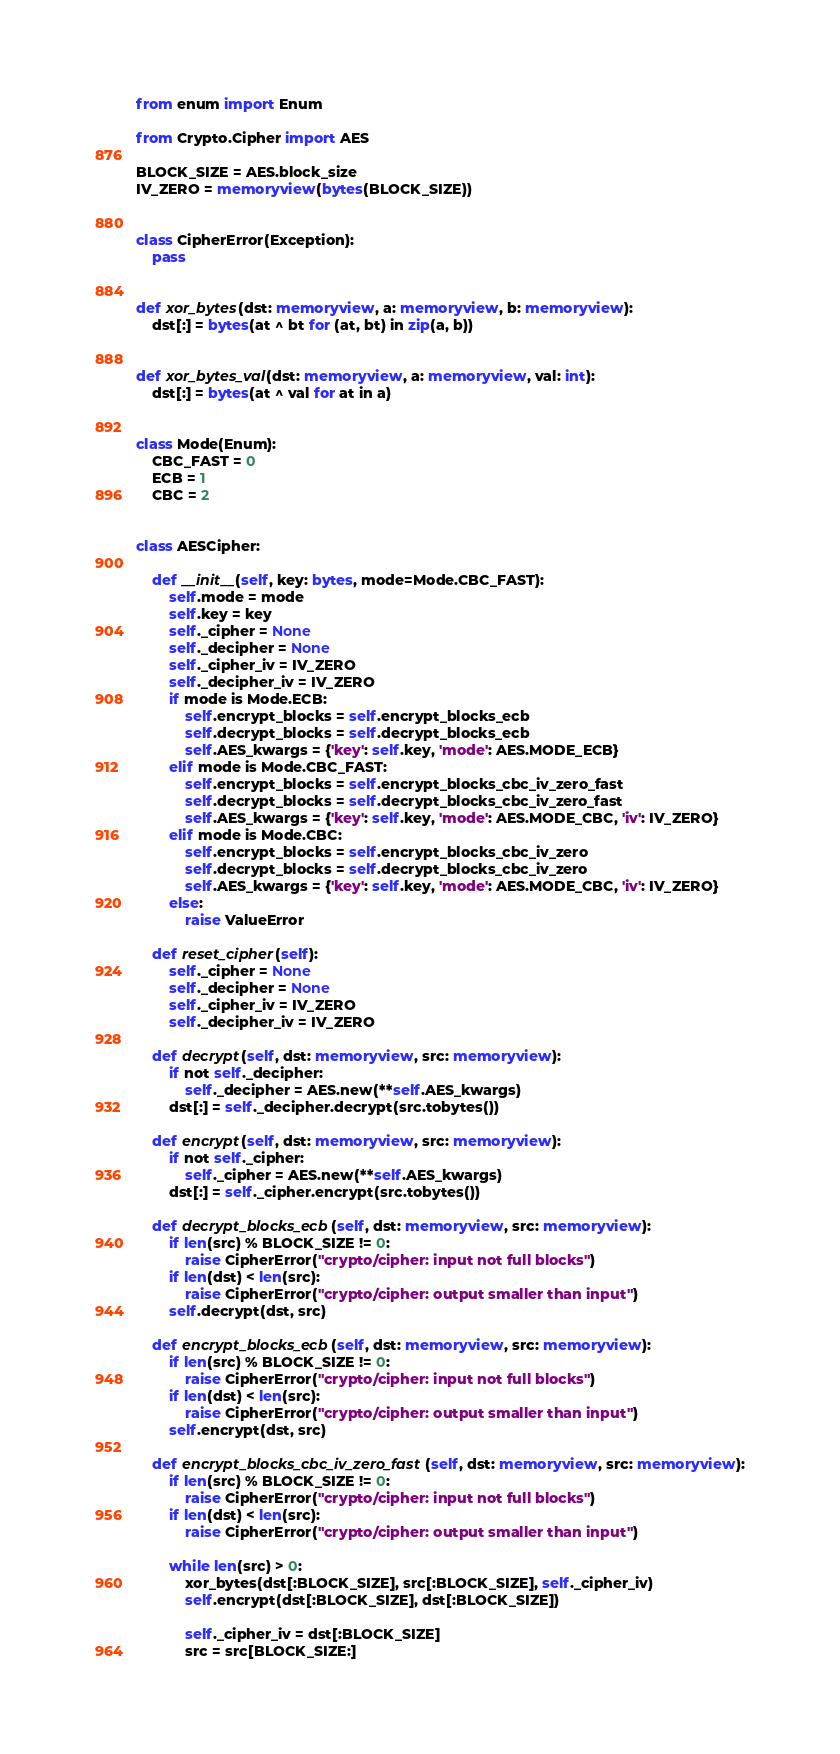Convert code to text. <code><loc_0><loc_0><loc_500><loc_500><_Python_>from enum import Enum

from Crypto.Cipher import AES

BLOCK_SIZE = AES.block_size
IV_ZERO = memoryview(bytes(BLOCK_SIZE))


class CipherError(Exception):
    pass


def xor_bytes(dst: memoryview, a: memoryview, b: memoryview):
    dst[:] = bytes(at ^ bt for (at, bt) in zip(a, b))


def xor_bytes_val(dst: memoryview, a: memoryview, val: int):
    dst[:] = bytes(at ^ val for at in a)


class Mode(Enum):
    CBC_FAST = 0
    ECB = 1
    CBC = 2


class AESCipher:

    def __init__(self, key: bytes, mode=Mode.CBC_FAST):
        self.mode = mode
        self.key = key
        self._cipher = None
        self._decipher = None
        self._cipher_iv = IV_ZERO
        self._decipher_iv = IV_ZERO
        if mode is Mode.ECB:
            self.encrypt_blocks = self.encrypt_blocks_ecb
            self.decrypt_blocks = self.decrypt_blocks_ecb
            self.AES_kwargs = {'key': self.key, 'mode': AES.MODE_ECB}
        elif mode is Mode.CBC_FAST:
            self.encrypt_blocks = self.encrypt_blocks_cbc_iv_zero_fast
            self.decrypt_blocks = self.decrypt_blocks_cbc_iv_zero_fast
            self.AES_kwargs = {'key': self.key, 'mode': AES.MODE_CBC, 'iv': IV_ZERO}
        elif mode is Mode.CBC:
            self.encrypt_blocks = self.encrypt_blocks_cbc_iv_zero
            self.decrypt_blocks = self.decrypt_blocks_cbc_iv_zero
            self.AES_kwargs = {'key': self.key, 'mode': AES.MODE_CBC, 'iv': IV_ZERO}
        else:
            raise ValueError

    def reset_cipher(self):
        self._cipher = None
        self._decipher = None
        self._cipher_iv = IV_ZERO
        self._decipher_iv = IV_ZERO

    def decrypt(self, dst: memoryview, src: memoryview):
        if not self._decipher:
            self._decipher = AES.new(**self.AES_kwargs)
        dst[:] = self._decipher.decrypt(src.tobytes())

    def encrypt(self, dst: memoryview, src: memoryview):
        if not self._cipher:
            self._cipher = AES.new(**self.AES_kwargs)
        dst[:] = self._cipher.encrypt(src.tobytes())

    def decrypt_blocks_ecb(self, dst: memoryview, src: memoryview):
        if len(src) % BLOCK_SIZE != 0:
            raise CipherError("crypto/cipher: input not full blocks")
        if len(dst) < len(src):
            raise CipherError("crypto/cipher: output smaller than input")
        self.decrypt(dst, src)

    def encrypt_blocks_ecb(self, dst: memoryview, src: memoryview):
        if len(src) % BLOCK_SIZE != 0:
            raise CipherError("crypto/cipher: input not full blocks")
        if len(dst) < len(src):
            raise CipherError("crypto/cipher: output smaller than input")
        self.encrypt(dst, src)

    def encrypt_blocks_cbc_iv_zero_fast(self, dst: memoryview, src: memoryview):
        if len(src) % BLOCK_SIZE != 0:
            raise CipherError("crypto/cipher: input not full blocks")
        if len(dst) < len(src):
            raise CipherError("crypto/cipher: output smaller than input")

        while len(src) > 0:
            xor_bytes(dst[:BLOCK_SIZE], src[:BLOCK_SIZE], self._cipher_iv)
            self.encrypt(dst[:BLOCK_SIZE], dst[:BLOCK_SIZE])

            self._cipher_iv = dst[:BLOCK_SIZE]
            src = src[BLOCK_SIZE:]</code> 